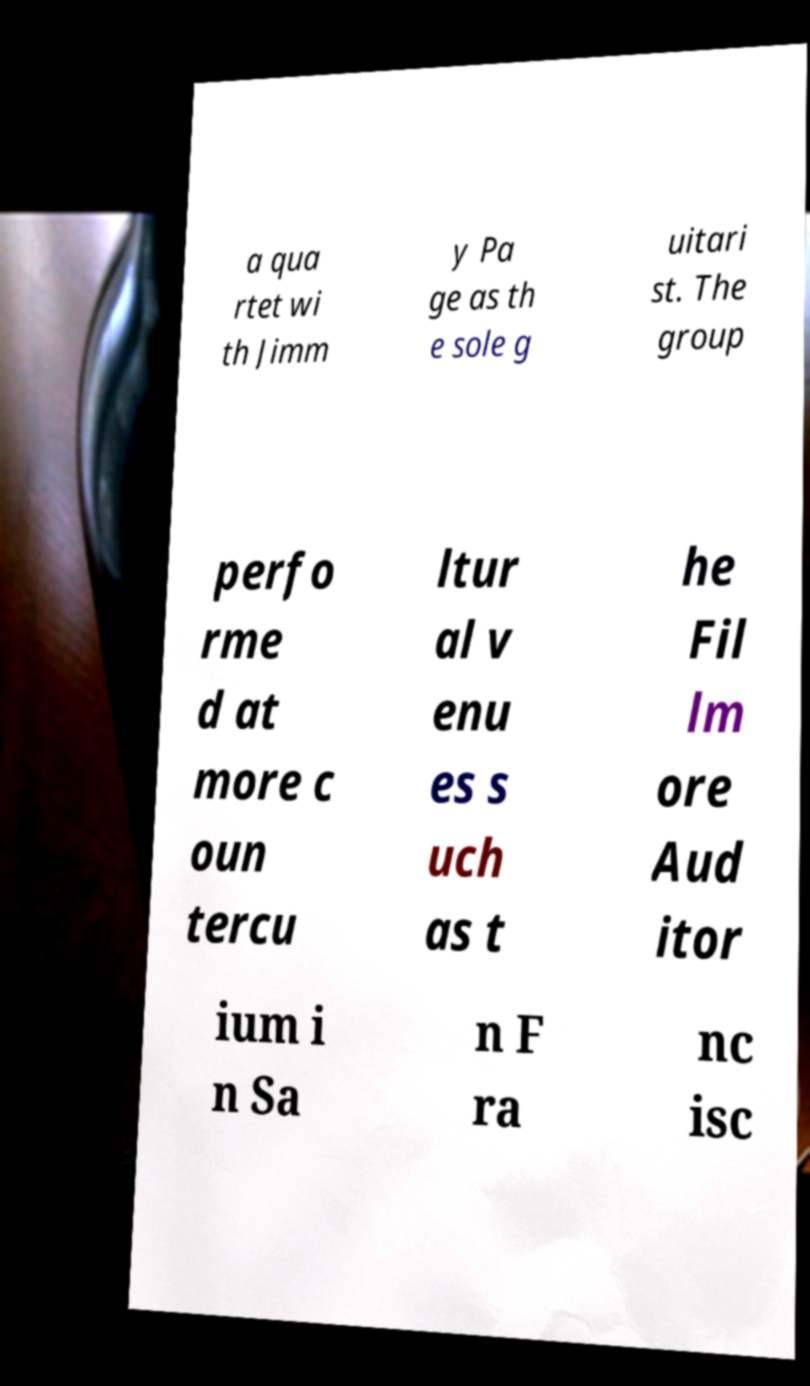Could you assist in decoding the text presented in this image and type it out clearly? a qua rtet wi th Jimm y Pa ge as th e sole g uitari st. The group perfo rme d at more c oun tercu ltur al v enu es s uch as t he Fil lm ore Aud itor ium i n Sa n F ra nc isc 